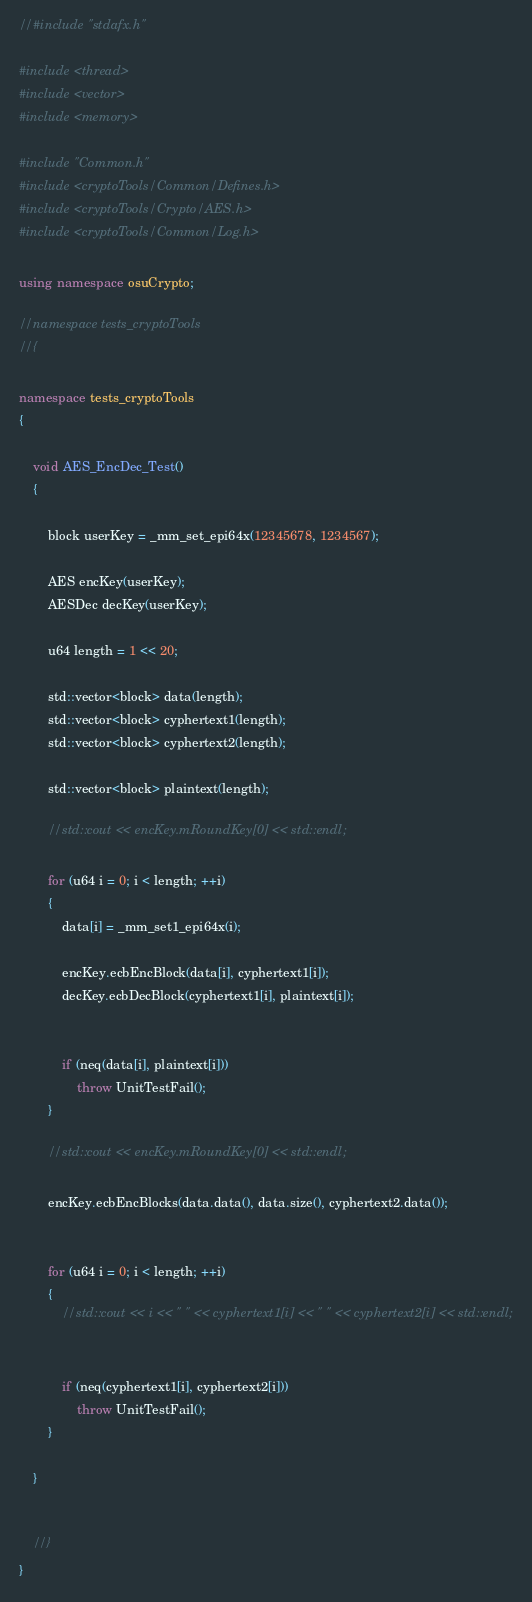<code> <loc_0><loc_0><loc_500><loc_500><_C++_>//#include "stdafx.h"

#include <thread>
#include <vector>
#include <memory>

#include "Common.h"
#include <cryptoTools/Common/Defines.h>
#include <cryptoTools/Crypto/AES.h> 
#include <cryptoTools/Common/Log.h>

using namespace osuCrypto;

//namespace tests_cryptoTools
//{

namespace tests_cryptoTools
{

    void AES_EncDec_Test()
    {

        block userKey = _mm_set_epi64x(12345678, 1234567);

        AES encKey(userKey);
        AESDec decKey(userKey);

        u64 length = 1 << 20;

        std::vector<block> data(length);
        std::vector<block> cyphertext1(length);
        std::vector<block> cyphertext2(length);

        std::vector<block> plaintext(length);

        //std::cout << encKey.mRoundKey[0] << std::endl;

        for (u64 i = 0; i < length; ++i)
        {
            data[i] = _mm_set1_epi64x(i);

            encKey.ecbEncBlock(data[i], cyphertext1[i]);
            decKey.ecbDecBlock(cyphertext1[i], plaintext[i]);


            if (neq(data[i], plaintext[i]))
                throw UnitTestFail();
        }

        //std::cout << encKey.mRoundKey[0] << std::endl;

        encKey.ecbEncBlocks(data.data(), data.size(), cyphertext2.data());


        for (u64 i = 0; i < length; ++i)
        {
            //std::cout << i << " " << cyphertext1[i] << " " << cyphertext2[i] << std::endl;


            if (neq(cyphertext1[i], cyphertext2[i]))
                throw UnitTestFail();
        }

    }


    //}
}</code> 